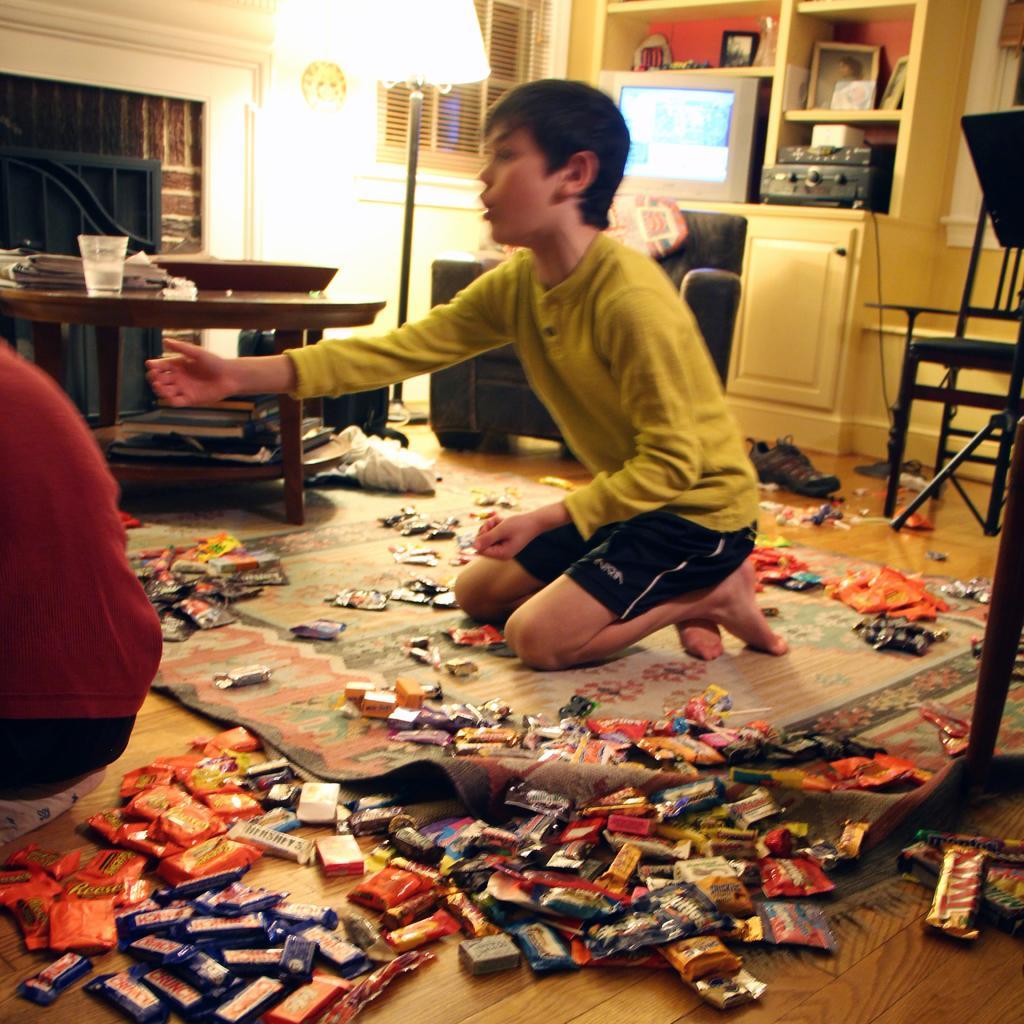Could you give a brief overview of what you see in this image? The picture is inside home ,there are a lot of chocolates and toffees on the floor, the kid is collecting the toffees, behind him there is a cupboard and a television and some photo frames,to his right side there is a table in the background there is a lamp and a window. 